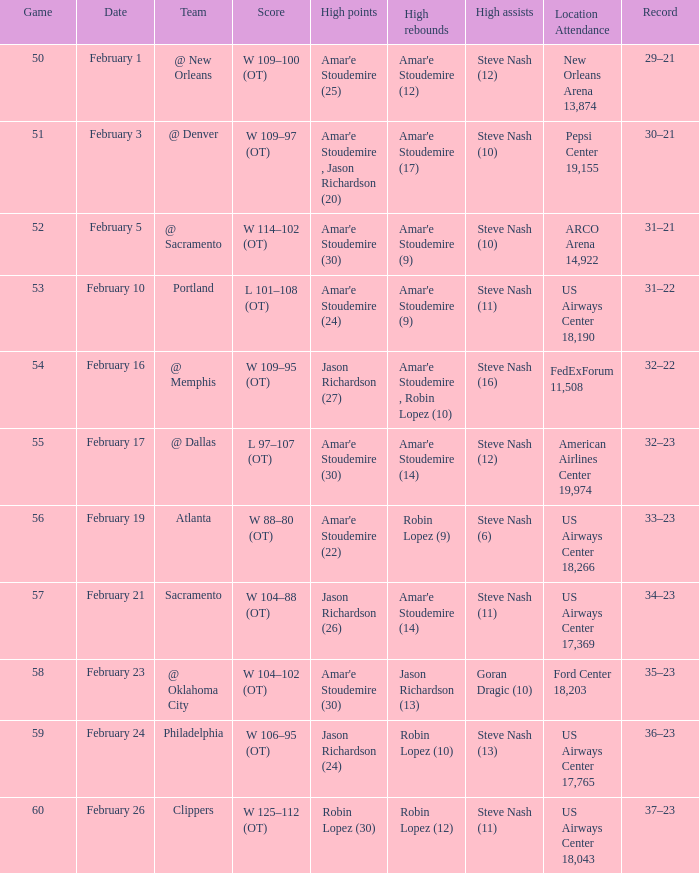Name the high points for pepsi center 19,155 Amar'e Stoudemire , Jason Richardson (20). 